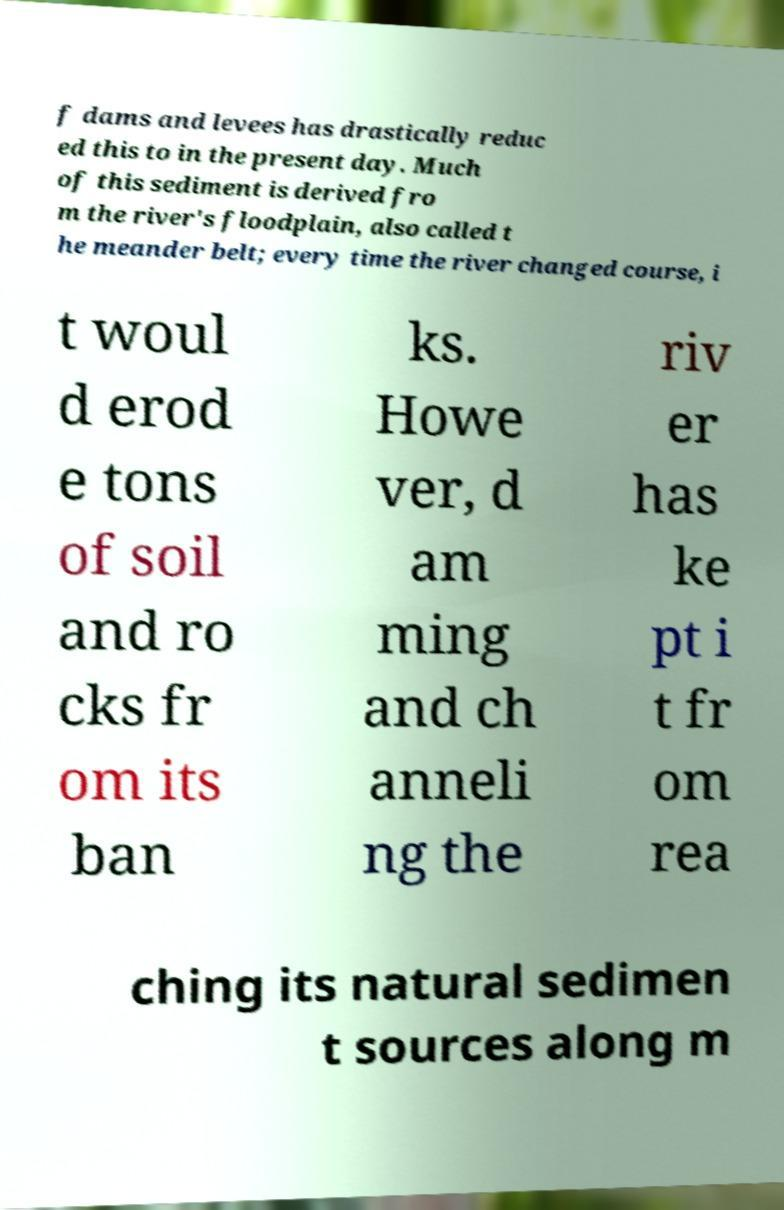What messages or text are displayed in this image? I need them in a readable, typed format. f dams and levees has drastically reduc ed this to in the present day. Much of this sediment is derived fro m the river's floodplain, also called t he meander belt; every time the river changed course, i t woul d erod e tons of soil and ro cks fr om its ban ks. Howe ver, d am ming and ch anneli ng the riv er has ke pt i t fr om rea ching its natural sedimen t sources along m 